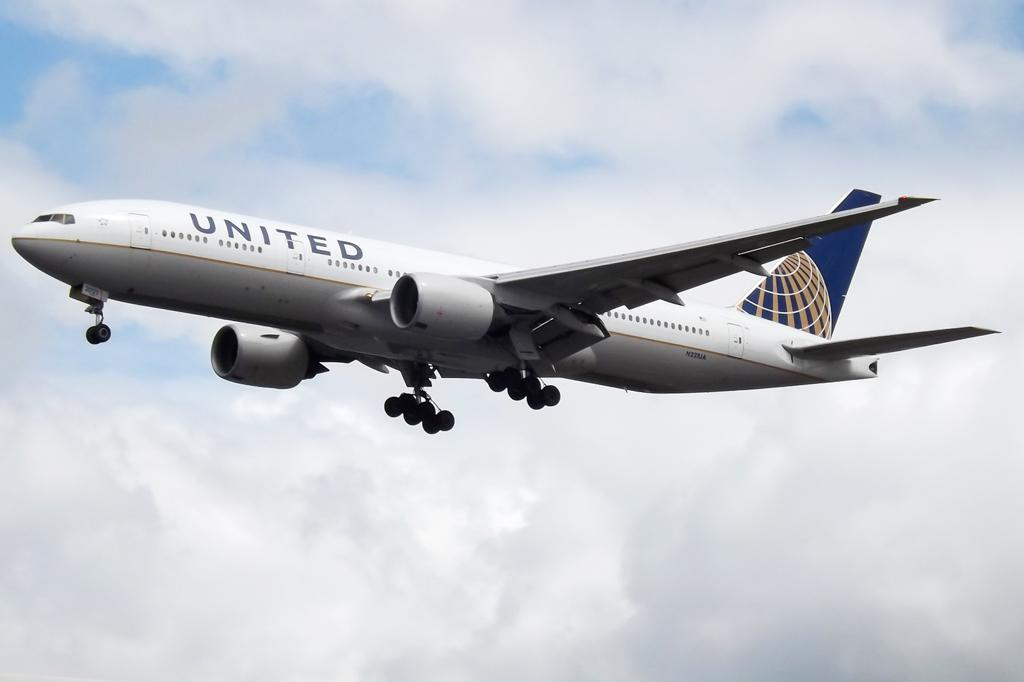Provide a one-sentence caption for the provided image. United Airplanes is flying in the air by itself. 